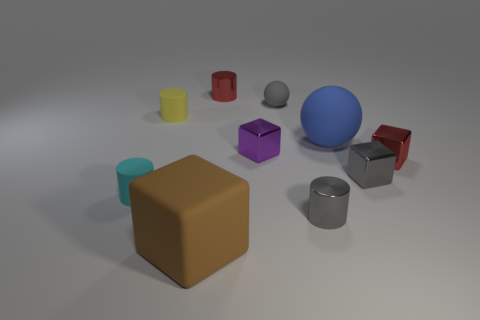Subtract 1 blocks. How many blocks are left? 3 Subtract all green cylinders. Subtract all green cubes. How many cylinders are left? 4 Subtract all balls. How many objects are left? 8 Subtract 1 red cubes. How many objects are left? 9 Subtract all big gray matte things. Subtract all yellow rubber cylinders. How many objects are left? 9 Add 6 tiny purple metallic cubes. How many tiny purple metallic cubes are left? 7 Add 1 gray cylinders. How many gray cylinders exist? 2 